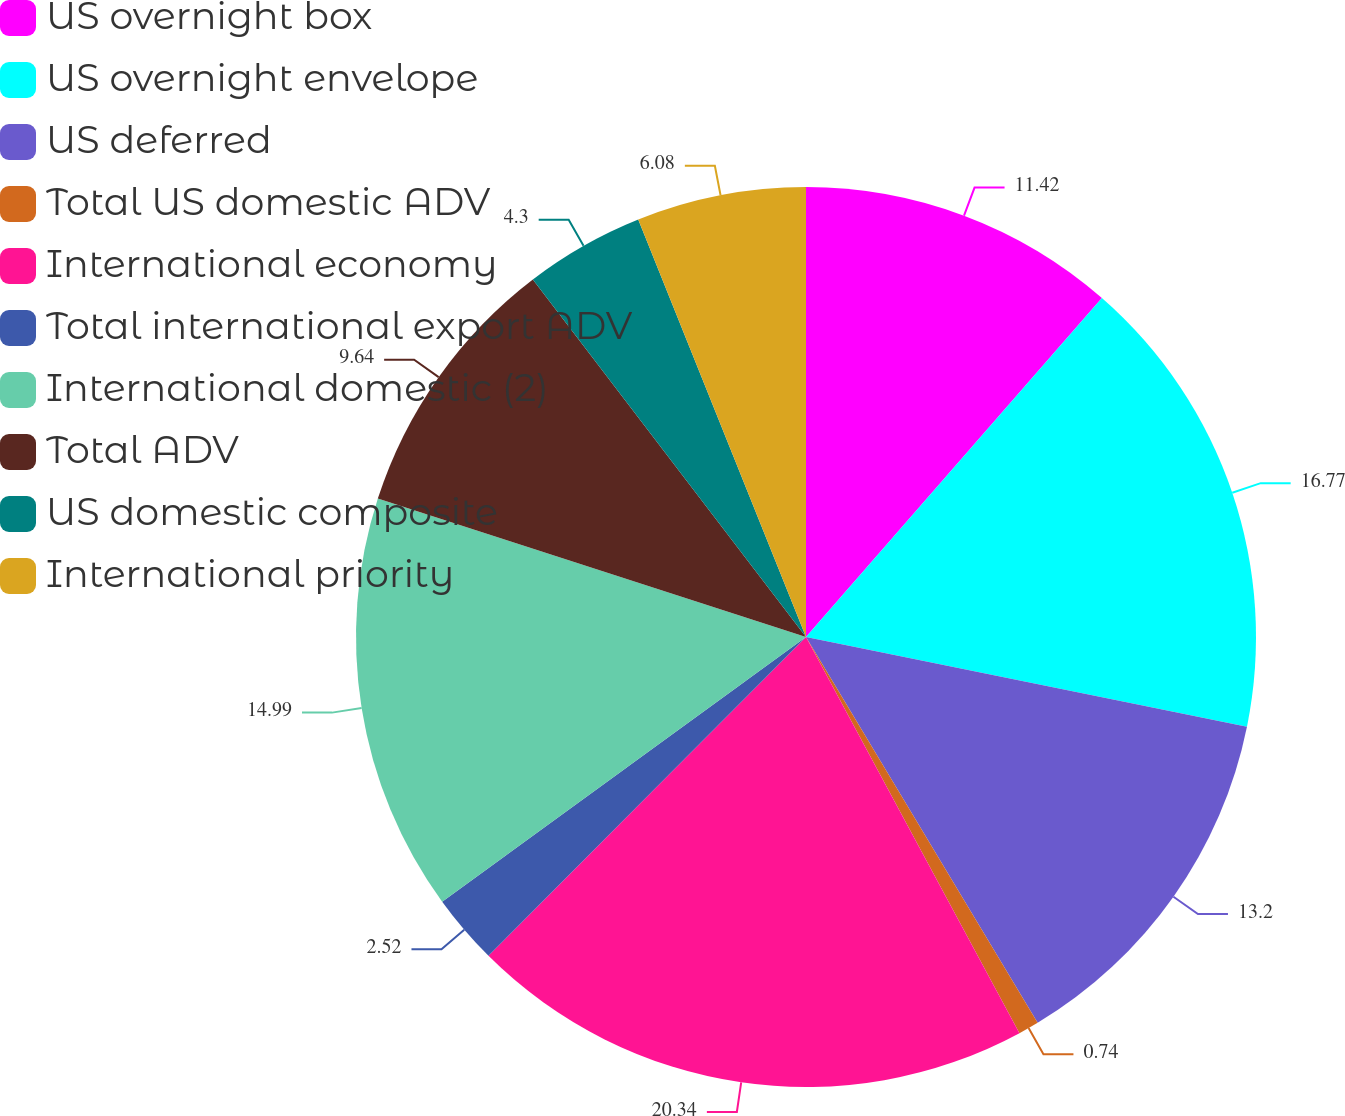<chart> <loc_0><loc_0><loc_500><loc_500><pie_chart><fcel>US overnight box<fcel>US overnight envelope<fcel>US deferred<fcel>Total US domestic ADV<fcel>International economy<fcel>Total international export ADV<fcel>International domestic (2)<fcel>Total ADV<fcel>US domestic composite<fcel>International priority<nl><fcel>11.42%<fcel>16.77%<fcel>13.2%<fcel>0.74%<fcel>20.33%<fcel>2.52%<fcel>14.99%<fcel>9.64%<fcel>4.3%<fcel>6.08%<nl></chart> 